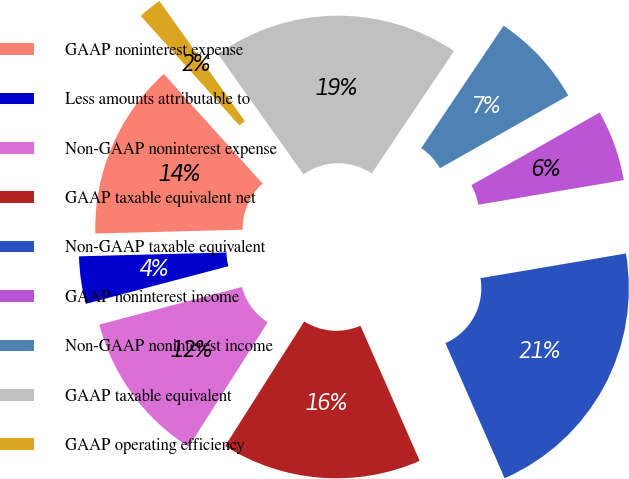<chart> <loc_0><loc_0><loc_500><loc_500><pie_chart><fcel>GAAP noninterest expense<fcel>Less amounts attributable to<fcel>Non-GAAP noninterest expense<fcel>GAAP taxable equivalent net<fcel>Non-GAAP taxable equivalent<fcel>GAAP noninterest income<fcel>Non-GAAP noninterest income<fcel>GAAP taxable equivalent<fcel>GAAP operating efficiency<nl><fcel>13.74%<fcel>3.69%<fcel>11.89%<fcel>15.58%<fcel>21.1%<fcel>5.53%<fcel>7.37%<fcel>19.26%<fcel>1.84%<nl></chart> 